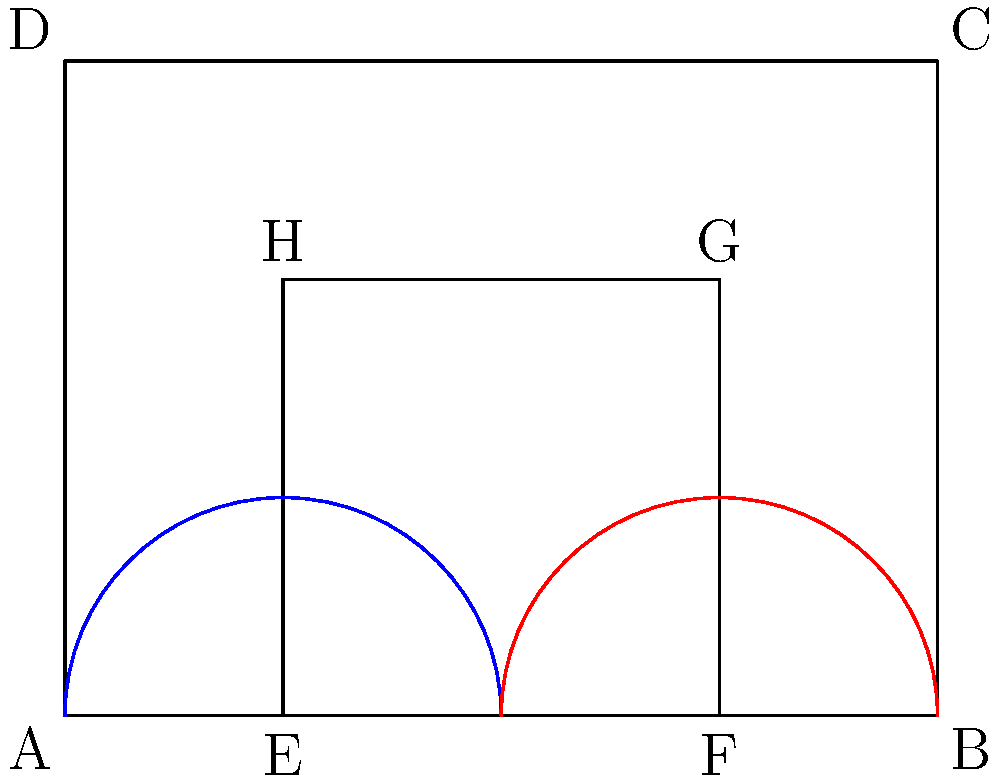In the mission-style building facade shown above, two arches are depicted. Are these arches congruent? If so, explain why. If not, what transformation would make them congruent? To determine if the arches are congruent, we need to analyze their properties:

1. Both arches are semicircles, which is typical in mission-style architecture.

2. The blue arch is centered at point E, while the red arch is centered at point F.

3. The distance between E and F is 2 units (from 1 to 3 on the x-axis).

4. Both arches have the same radius of 1 unit, as they span from their respective center points to the edges of their bases.

5. In geometry, two circles (or semicircles) are congruent if and only if they have the same radius.

6. Since both arches have the same radius of 1 unit, they are indeed congruent.

7. No transformation is needed to make them congruent, as they already are.

8. The only difference between the two arches is their position, which does not affect congruence.

Therefore, the two arches in the mission-style facade are congruent, reflecting the symmetry and harmony often found in such architectural designs.
Answer: Yes, the arches are congruent because they have the same radius. 